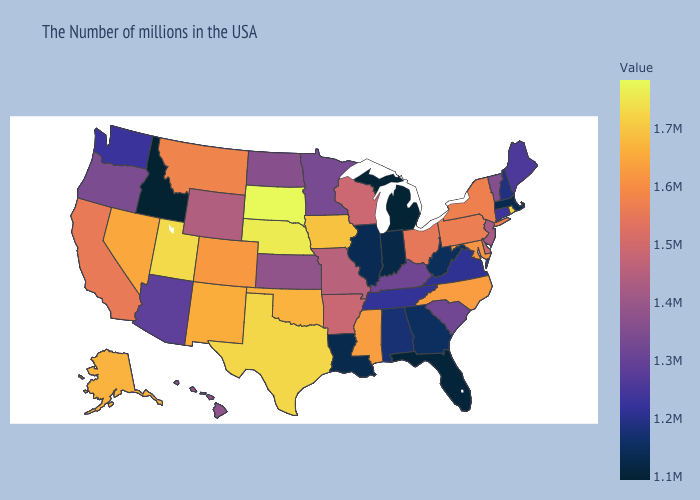Does Wisconsin have a lower value than Oklahoma?
Quick response, please. Yes. Does North Carolina have a higher value than Minnesota?
Give a very brief answer. Yes. Does Vermont have a higher value than California?
Write a very short answer. No. Which states have the lowest value in the USA?
Be succinct. Idaho. Which states hav the highest value in the West?
Concise answer only. Utah. Does North Carolina have the lowest value in the South?
Concise answer only. No. 